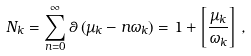Convert formula to latex. <formula><loc_0><loc_0><loc_500><loc_500>N _ { k } = \sum _ { n = 0 } ^ { \infty } \theta \left ( \mu _ { k } - n \omega _ { k } \right ) = 1 + \left [ \frac { \mu _ { k } } { \omega _ { k } } \right ] \, ,</formula> 